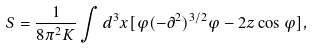Convert formula to latex. <formula><loc_0><loc_0><loc_500><loc_500>S = \frac { 1 } { 8 \pi ^ { 2 } K } \int d ^ { 3 } x [ \varphi ( - \partial ^ { 2 } ) ^ { 3 / 2 } \varphi - 2 z \cos \varphi ] ,</formula> 